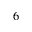<formula> <loc_0><loc_0><loc_500><loc_500>_ { 6 }</formula> 